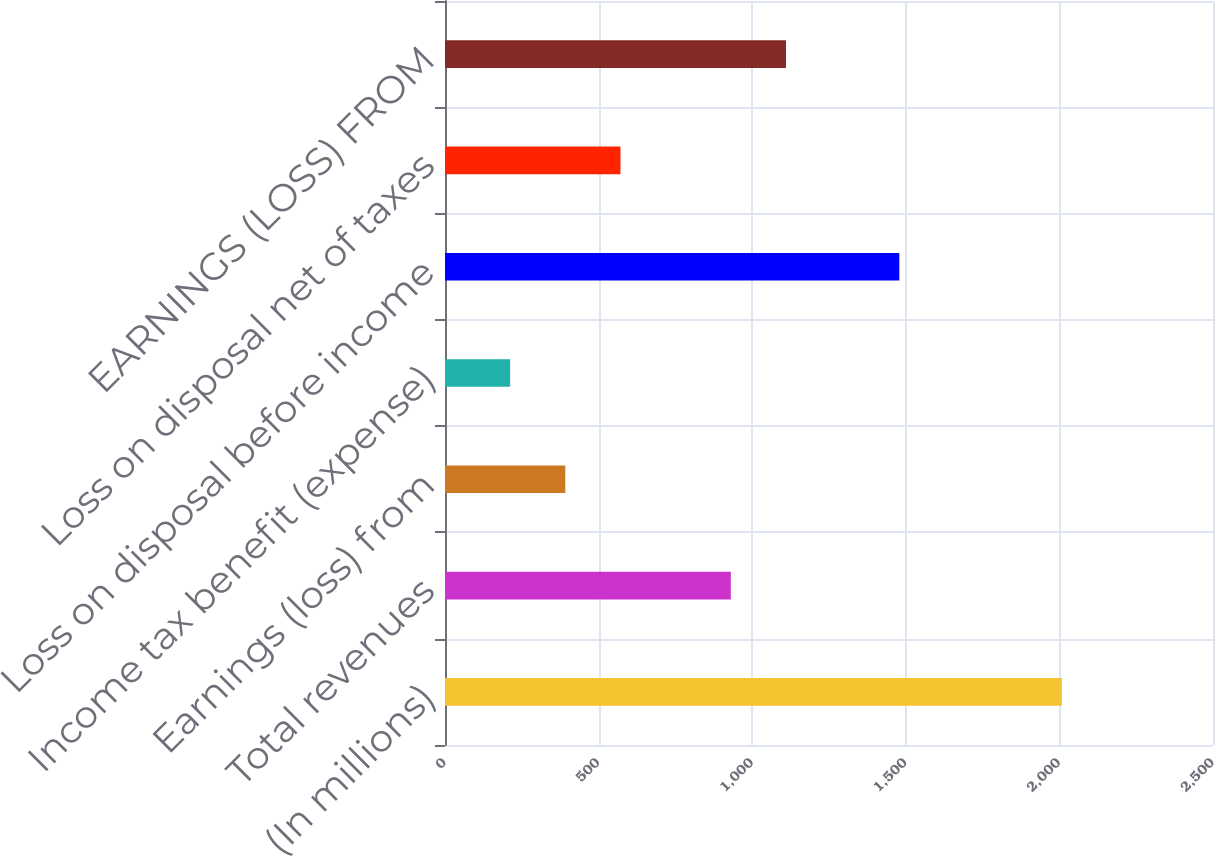<chart> <loc_0><loc_0><loc_500><loc_500><bar_chart><fcel>(In millions)<fcel>Total revenues<fcel>Earnings (loss) from<fcel>Income tax benefit (expense)<fcel>Loss on disposal before income<fcel>Loss on disposal net of taxes<fcel>EARNINGS (LOSS) FROM<nl><fcel>2008<fcel>930.4<fcel>391.6<fcel>212<fcel>1479<fcel>571.2<fcel>1110<nl></chart> 